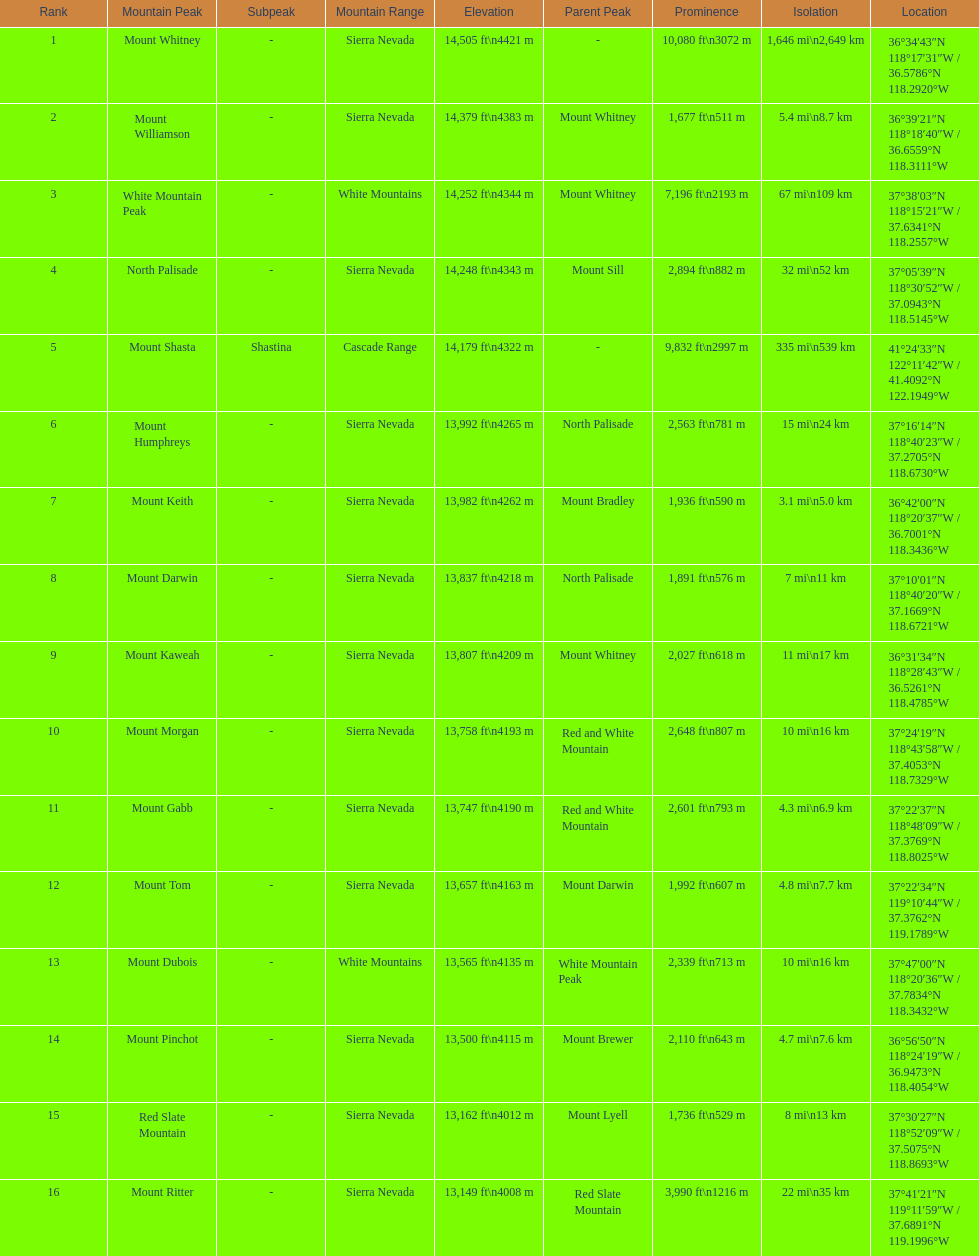Which mountain peak has the most isolation? Mount Whitney. 